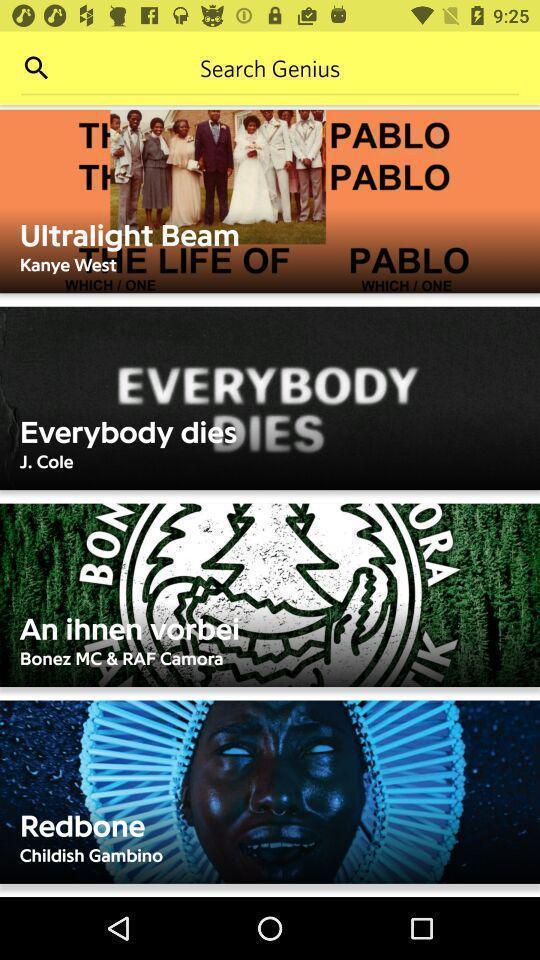What is the overall content of this screenshot? Search page to find songs and different tracks displayed. 